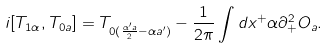<formula> <loc_0><loc_0><loc_500><loc_500>i [ T _ { 1 \alpha } , T _ { 0 a } ] = T _ { 0 ( \frac { \alpha ^ { \prime } a } { 2 } - \alpha a ^ { \prime } ) } - \frac { 1 } { 2 \pi } \int d x ^ { + } \alpha \partial _ { + } ^ { 2 } O _ { a } .</formula> 